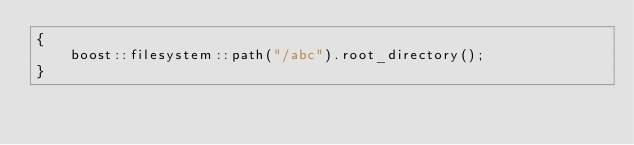Convert code to text. <code><loc_0><loc_0><loc_500><loc_500><_C++_>{
    boost::filesystem::path("/abc").root_directory();
}
</code> 